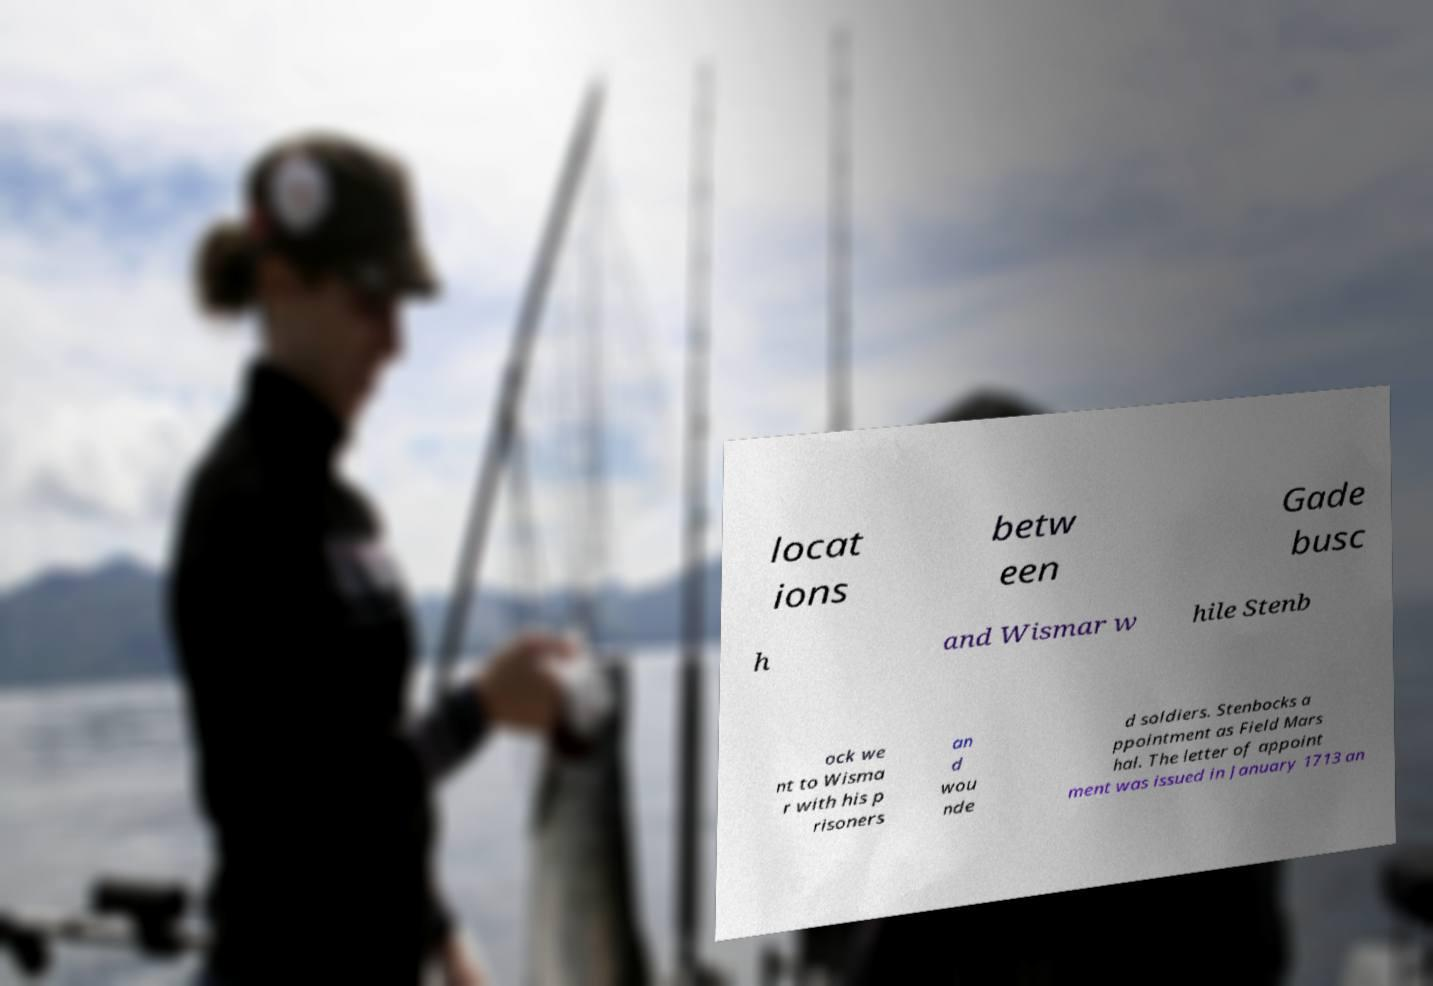Please read and relay the text visible in this image. What does it say? locat ions betw een Gade busc h and Wismar w hile Stenb ock we nt to Wisma r with his p risoners an d wou nde d soldiers. Stenbocks a ppointment as Field Mars hal. The letter of appoint ment was issued in January 1713 an 